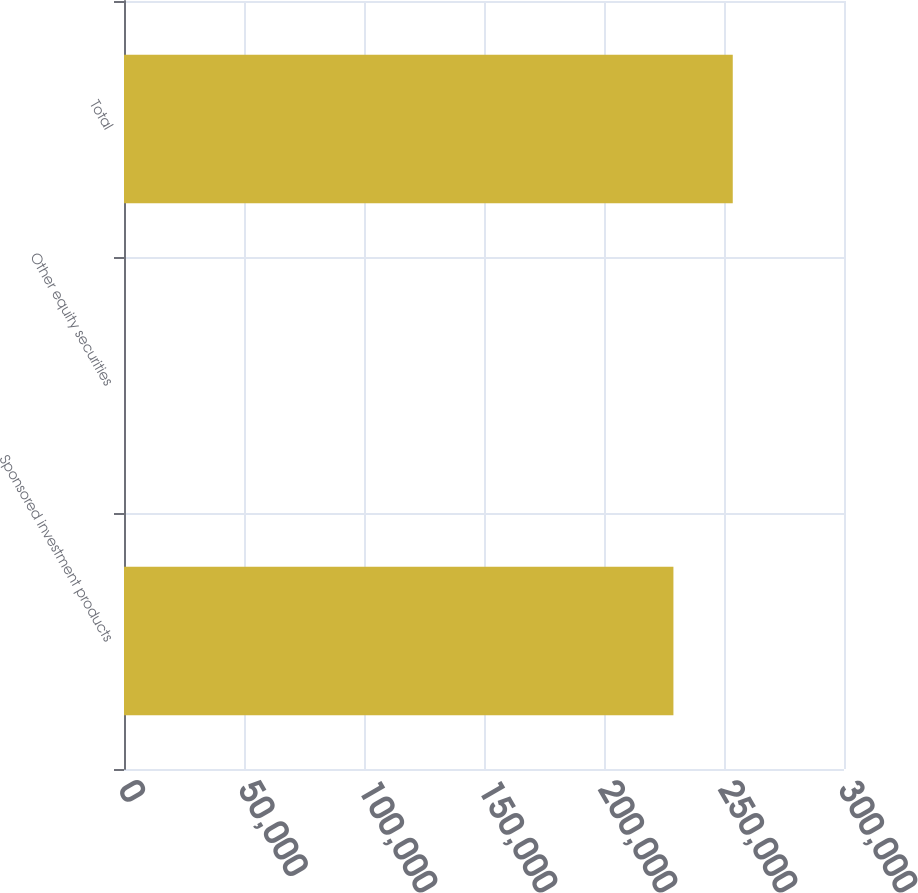Convert chart to OTSL. <chart><loc_0><loc_0><loc_500><loc_500><bar_chart><fcel>Sponsored investment products<fcel>Other equity securities<fcel>Total<nl><fcel>228926<fcel>8<fcel>253649<nl></chart> 